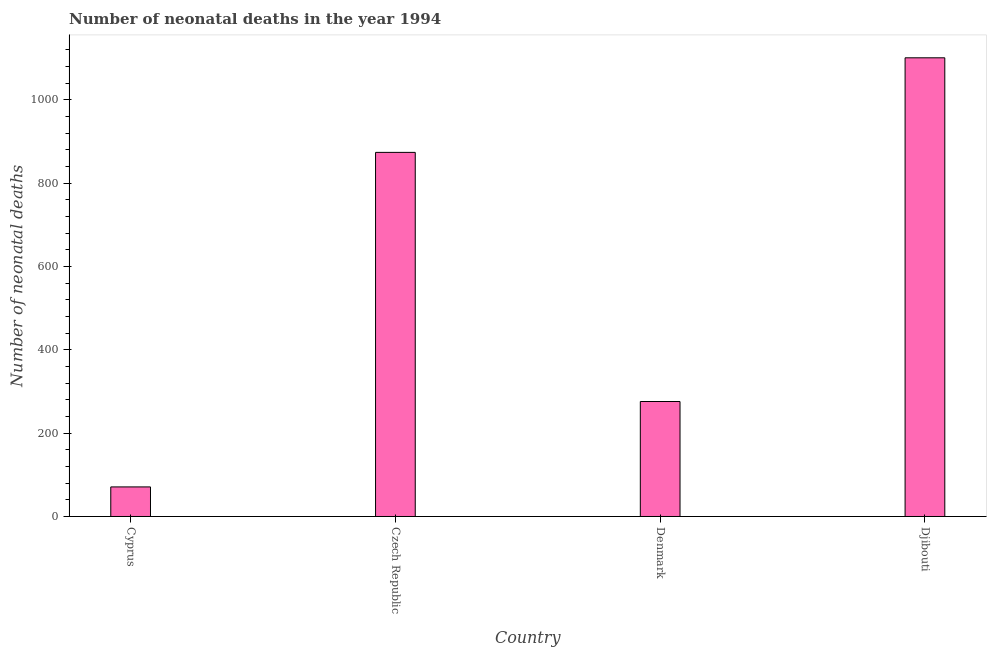What is the title of the graph?
Offer a terse response. Number of neonatal deaths in the year 1994. What is the label or title of the X-axis?
Offer a very short reply. Country. What is the label or title of the Y-axis?
Your response must be concise. Number of neonatal deaths. What is the number of neonatal deaths in Denmark?
Provide a succinct answer. 276. Across all countries, what is the maximum number of neonatal deaths?
Offer a very short reply. 1101. In which country was the number of neonatal deaths maximum?
Keep it short and to the point. Djibouti. In which country was the number of neonatal deaths minimum?
Provide a succinct answer. Cyprus. What is the sum of the number of neonatal deaths?
Your answer should be very brief. 2322. What is the difference between the number of neonatal deaths in Cyprus and Denmark?
Ensure brevity in your answer.  -205. What is the average number of neonatal deaths per country?
Provide a succinct answer. 580. What is the median number of neonatal deaths?
Keep it short and to the point. 575. What is the ratio of the number of neonatal deaths in Cyprus to that in Djibouti?
Make the answer very short. 0.06. Is the difference between the number of neonatal deaths in Czech Republic and Djibouti greater than the difference between any two countries?
Your answer should be compact. No. What is the difference between the highest and the second highest number of neonatal deaths?
Provide a short and direct response. 227. Is the sum of the number of neonatal deaths in Cyprus and Czech Republic greater than the maximum number of neonatal deaths across all countries?
Provide a succinct answer. No. What is the difference between the highest and the lowest number of neonatal deaths?
Keep it short and to the point. 1030. In how many countries, is the number of neonatal deaths greater than the average number of neonatal deaths taken over all countries?
Provide a short and direct response. 2. Are all the bars in the graph horizontal?
Your answer should be compact. No. How many countries are there in the graph?
Provide a short and direct response. 4. What is the Number of neonatal deaths in Cyprus?
Your response must be concise. 71. What is the Number of neonatal deaths in Czech Republic?
Offer a very short reply. 874. What is the Number of neonatal deaths in Denmark?
Keep it short and to the point. 276. What is the Number of neonatal deaths of Djibouti?
Ensure brevity in your answer.  1101. What is the difference between the Number of neonatal deaths in Cyprus and Czech Republic?
Your answer should be compact. -803. What is the difference between the Number of neonatal deaths in Cyprus and Denmark?
Your response must be concise. -205. What is the difference between the Number of neonatal deaths in Cyprus and Djibouti?
Your response must be concise. -1030. What is the difference between the Number of neonatal deaths in Czech Republic and Denmark?
Provide a short and direct response. 598. What is the difference between the Number of neonatal deaths in Czech Republic and Djibouti?
Give a very brief answer. -227. What is the difference between the Number of neonatal deaths in Denmark and Djibouti?
Keep it short and to the point. -825. What is the ratio of the Number of neonatal deaths in Cyprus to that in Czech Republic?
Your answer should be very brief. 0.08. What is the ratio of the Number of neonatal deaths in Cyprus to that in Denmark?
Keep it short and to the point. 0.26. What is the ratio of the Number of neonatal deaths in Cyprus to that in Djibouti?
Offer a very short reply. 0.06. What is the ratio of the Number of neonatal deaths in Czech Republic to that in Denmark?
Your answer should be very brief. 3.17. What is the ratio of the Number of neonatal deaths in Czech Republic to that in Djibouti?
Provide a short and direct response. 0.79. What is the ratio of the Number of neonatal deaths in Denmark to that in Djibouti?
Offer a terse response. 0.25. 